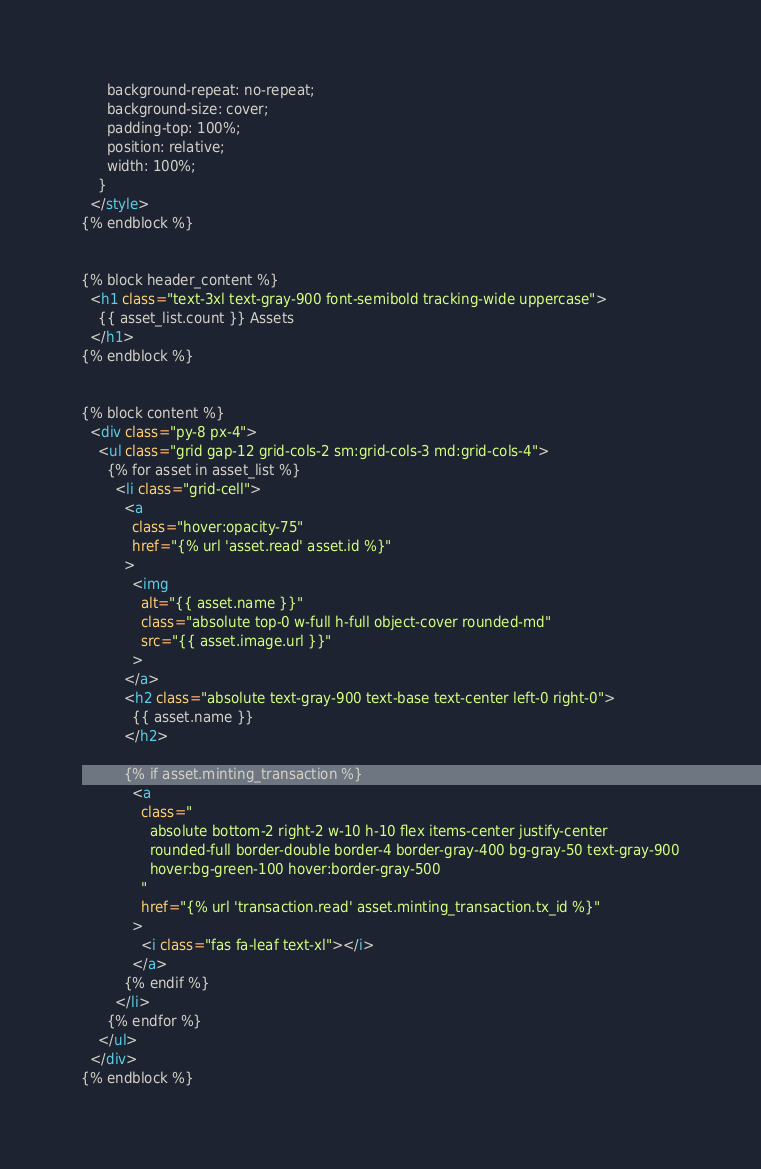Convert code to text. <code><loc_0><loc_0><loc_500><loc_500><_HTML_>      background-repeat: no-repeat;
      background-size: cover;
      padding-top: 100%;
      position: relative;
      width: 100%;
    }
  </style>
{% endblock %}


{% block header_content %}
  <h1 class="text-3xl text-gray-900 font-semibold tracking-wide uppercase">
    {{ asset_list.count }} Assets
  </h1>
{% endblock %}


{% block content %}
  <div class="py-8 px-4">
    <ul class="grid gap-12 grid-cols-2 sm:grid-cols-3 md:grid-cols-4">
      {% for asset in asset_list %}
        <li class="grid-cell">
          <a
            class="hover:opacity-75"
            href="{% url 'asset.read' asset.id %}"
          >
            <img
              alt="{{ asset.name }}"
              class="absolute top-0 w-full h-full object-cover rounded-md"
              src="{{ asset.image.url }}"
            >
          </a>
          <h2 class="absolute text-gray-900 text-base text-center left-0 right-0">
            {{ asset.name }}
          </h2>

          {% if asset.minting_transaction %}
            <a
              class="
                absolute bottom-2 right-2 w-10 h-10 flex items-center justify-center
                rounded-full border-double border-4 border-gray-400 bg-gray-50 text-gray-900
                hover:bg-green-100 hover:border-gray-500
              "
              href="{% url 'transaction.read' asset.minting_transaction.tx_id %}"
            >
              <i class="fas fa-leaf text-xl"></i>
            </a>
          {% endif %}
        </li>
      {% endfor %}
    </ul>
  </div>
{% endblock %}</code> 